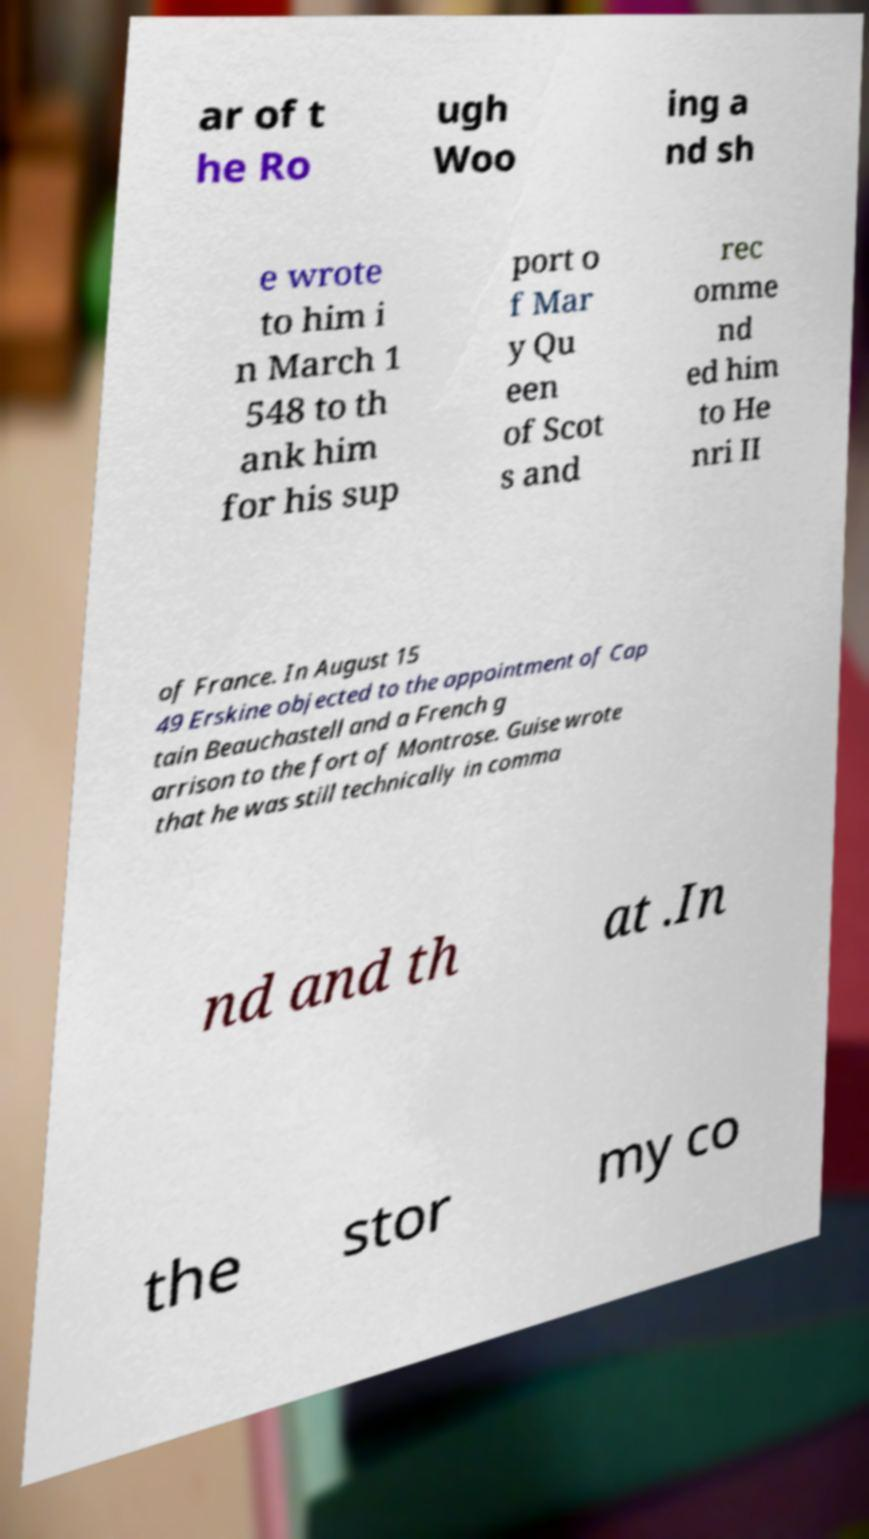Could you assist in decoding the text presented in this image and type it out clearly? ar of t he Ro ugh Woo ing a nd sh e wrote to him i n March 1 548 to th ank him for his sup port o f Mar y Qu een of Scot s and rec omme nd ed him to He nri II of France. In August 15 49 Erskine objected to the appointment of Cap tain Beauchastell and a French g arrison to the fort of Montrose. Guise wrote that he was still technically in comma nd and th at .In the stor my co 